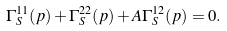<formula> <loc_0><loc_0><loc_500><loc_500>\Gamma _ { S } ^ { 1 1 } ( p ) + \Gamma _ { S } ^ { 2 2 } ( p ) + A \Gamma _ { S } ^ { 1 2 } ( p ) = 0 .</formula> 